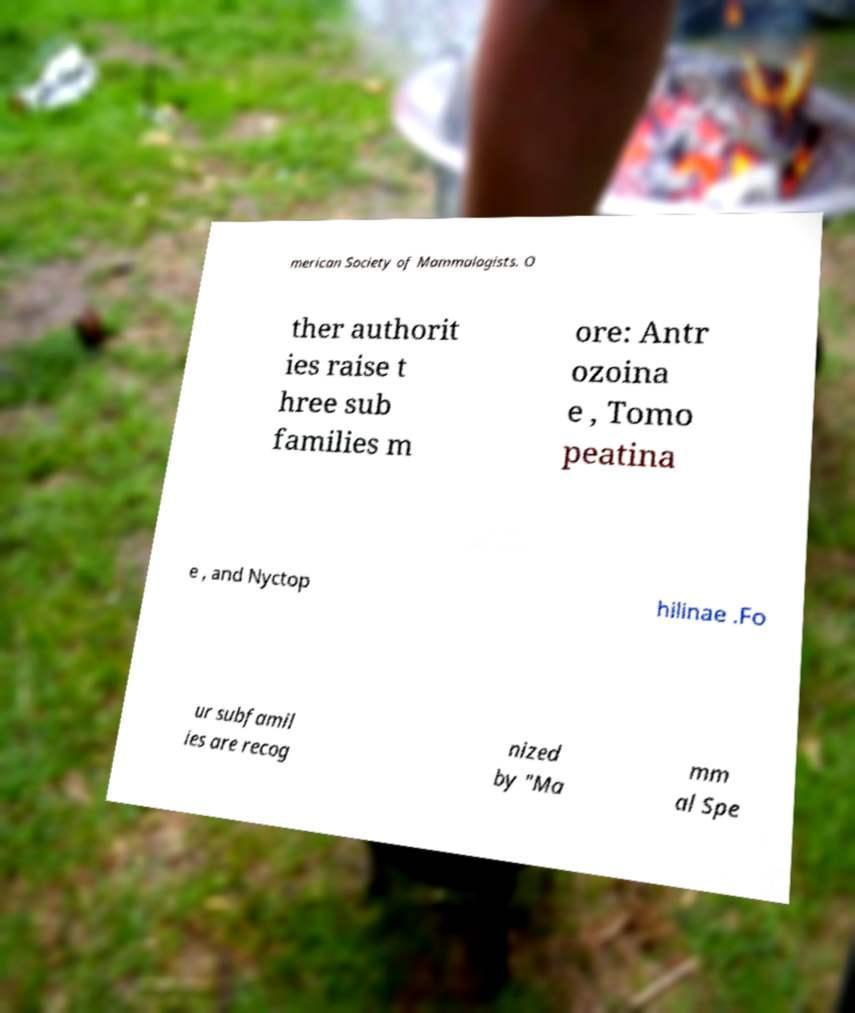What messages or text are displayed in this image? I need them in a readable, typed format. merican Society of Mammalogists. O ther authorit ies raise t hree sub families m ore: Antr ozoina e , Tomo peatina e , and Nyctop hilinae .Fo ur subfamil ies are recog nized by "Ma mm al Spe 